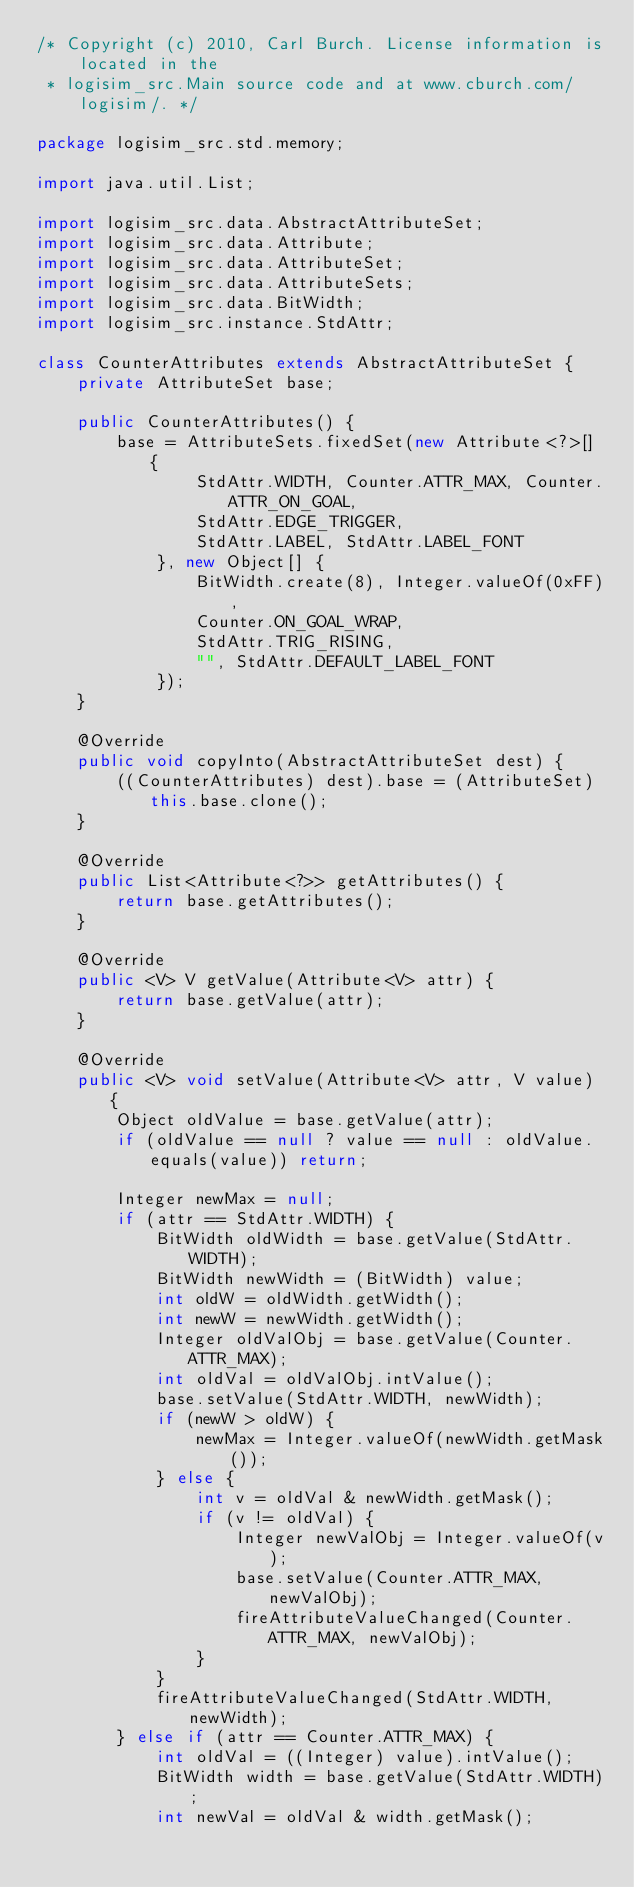<code> <loc_0><loc_0><loc_500><loc_500><_Java_>/* Copyright (c) 2010, Carl Burch. License information is located in the
 * logisim_src.Main source code and at www.cburch.com/logisim/. */

package logisim_src.std.memory;

import java.util.List;

import logisim_src.data.AbstractAttributeSet;
import logisim_src.data.Attribute;
import logisim_src.data.AttributeSet;
import logisim_src.data.AttributeSets;
import logisim_src.data.BitWidth;
import logisim_src.instance.StdAttr;

class CounterAttributes extends AbstractAttributeSet {
	private AttributeSet base;
	
	public CounterAttributes() {
		base = AttributeSets.fixedSet(new Attribute<?>[] {
				StdAttr.WIDTH, Counter.ATTR_MAX, Counter.ATTR_ON_GOAL,
				StdAttr.EDGE_TRIGGER,
				StdAttr.LABEL, StdAttr.LABEL_FONT
			}, new Object[] {
				BitWidth.create(8), Integer.valueOf(0xFF),
				Counter.ON_GOAL_WRAP,
				StdAttr.TRIG_RISING,
				"", StdAttr.DEFAULT_LABEL_FONT
			});
	}
	
	@Override
	public void copyInto(AbstractAttributeSet dest) {
		((CounterAttributes) dest).base = (AttributeSet) this.base.clone();
	}

	@Override
	public List<Attribute<?>> getAttributes() {
		return base.getAttributes();
	}

	@Override
	public <V> V getValue(Attribute<V> attr) {
		return base.getValue(attr);
	}

	@Override
	public <V> void setValue(Attribute<V> attr, V value) {
		Object oldValue = base.getValue(attr);
		if (oldValue == null ? value == null : oldValue.equals(value)) return;

		Integer newMax = null;
		if (attr == StdAttr.WIDTH) {
			BitWidth oldWidth = base.getValue(StdAttr.WIDTH);
			BitWidth newWidth = (BitWidth) value;
			int oldW = oldWidth.getWidth();
			int newW = newWidth.getWidth();
			Integer oldValObj = base.getValue(Counter.ATTR_MAX);
			int oldVal = oldValObj.intValue();
			base.setValue(StdAttr.WIDTH, newWidth);
			if (newW > oldW) {
				newMax = Integer.valueOf(newWidth.getMask());
			} else {
				int v = oldVal & newWidth.getMask();
				if (v != oldVal) {
					Integer newValObj = Integer.valueOf(v);
					base.setValue(Counter.ATTR_MAX, newValObj);
					fireAttributeValueChanged(Counter.ATTR_MAX, newValObj);
				}
			}
			fireAttributeValueChanged(StdAttr.WIDTH, newWidth);
		} else if (attr == Counter.ATTR_MAX) {
			int oldVal = ((Integer) value).intValue();
			BitWidth width = base.getValue(StdAttr.WIDTH);
			int newVal = oldVal & width.getMask();</code> 